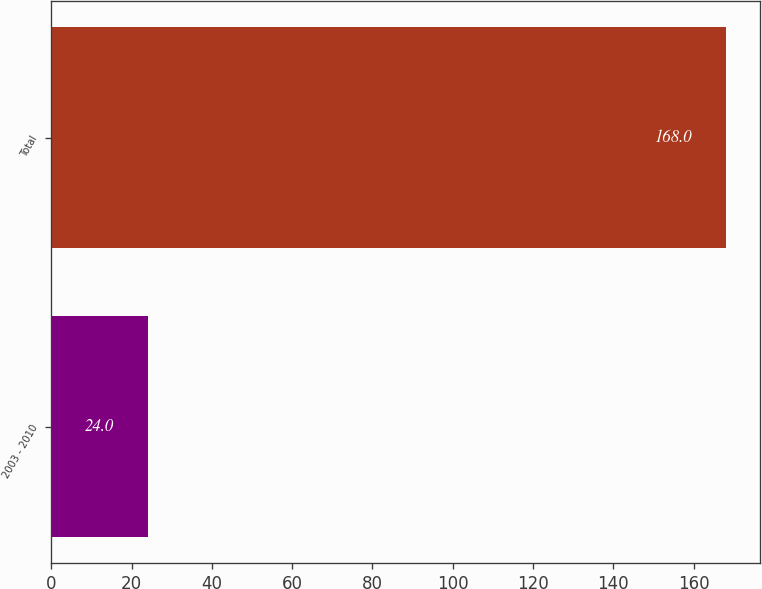<chart> <loc_0><loc_0><loc_500><loc_500><bar_chart><fcel>2003 - 2010<fcel>Total<nl><fcel>24<fcel>168<nl></chart> 